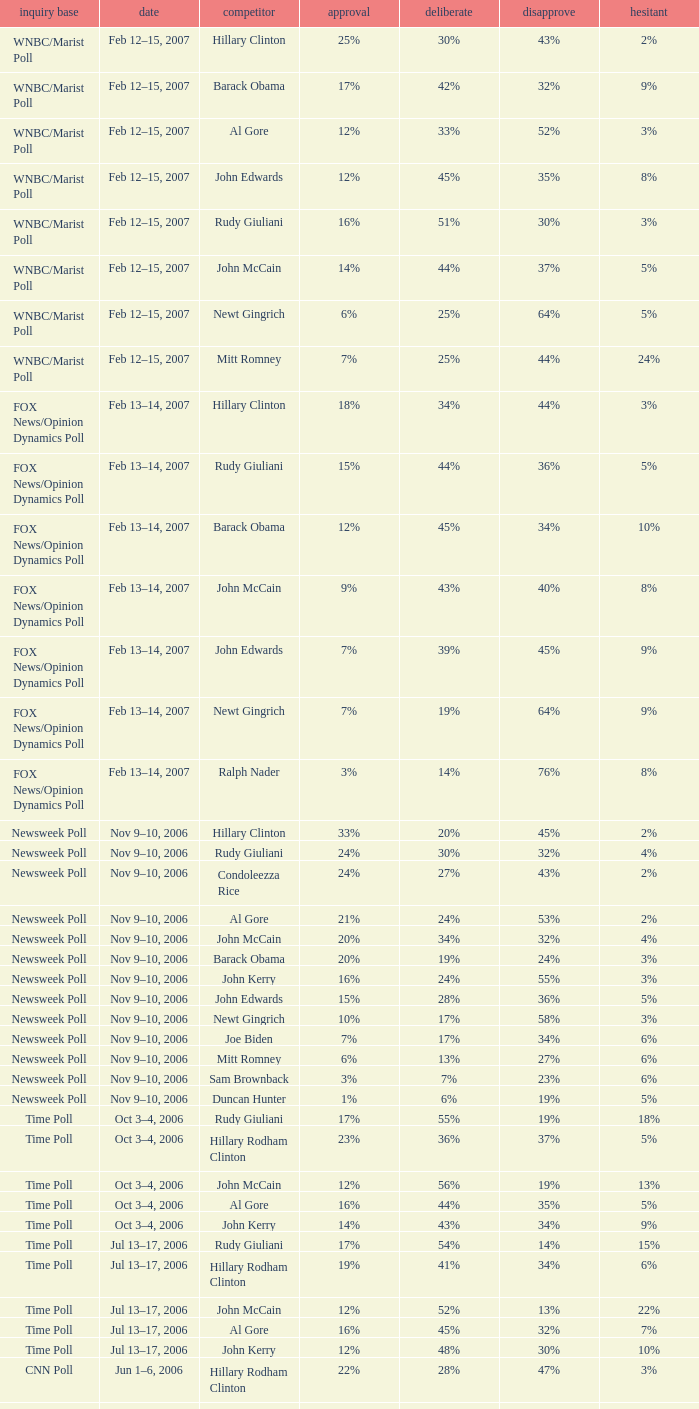What percentage of people were opposed to the candidate based on the WNBC/Marist poll that showed 8% of people were unsure? 35%. 